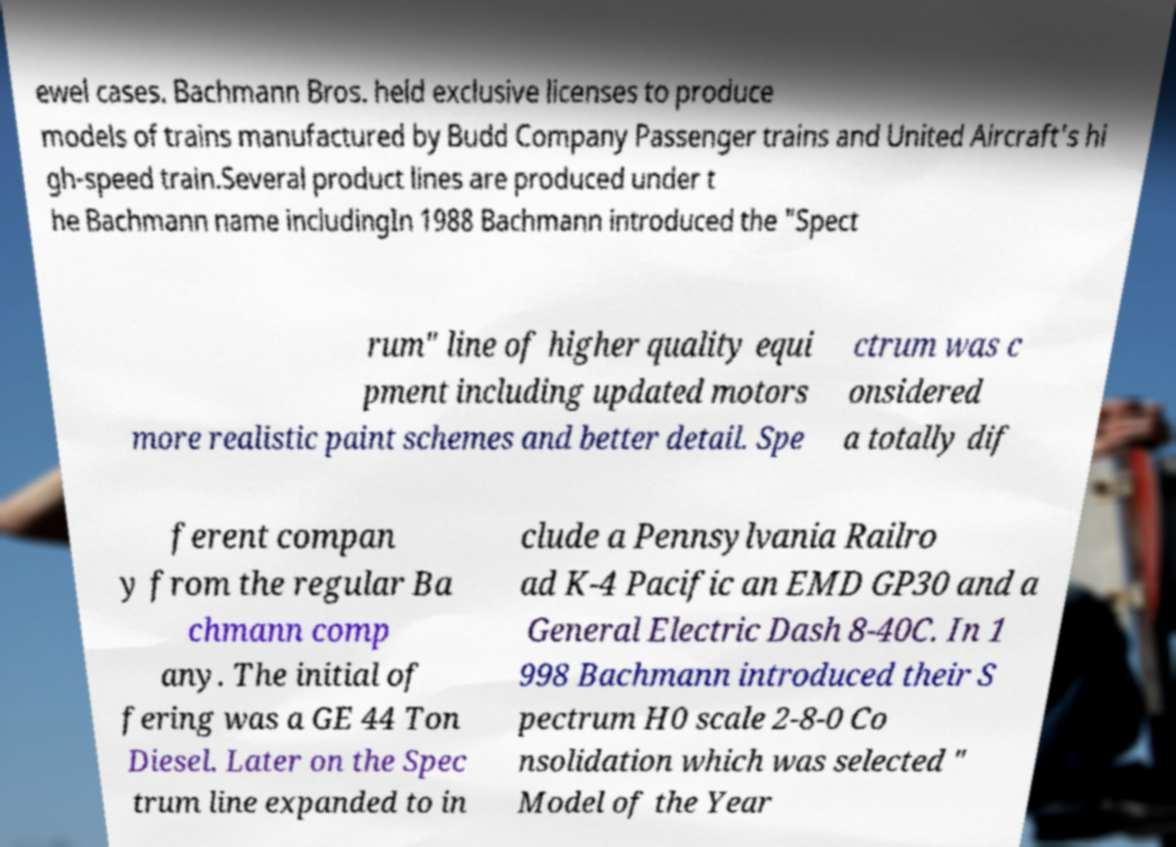Could you extract and type out the text from this image? ewel cases. Bachmann Bros. held exclusive licenses to produce models of trains manufactured by Budd Company Passenger trains and United Aircraft's hi gh-speed train.Several product lines are produced under t he Bachmann name includingIn 1988 Bachmann introduced the "Spect rum" line of higher quality equi pment including updated motors more realistic paint schemes and better detail. Spe ctrum was c onsidered a totally dif ferent compan y from the regular Ba chmann comp any. The initial of fering was a GE 44 Ton Diesel. Later on the Spec trum line expanded to in clude a Pennsylvania Railro ad K-4 Pacific an EMD GP30 and a General Electric Dash 8-40C. In 1 998 Bachmann introduced their S pectrum H0 scale 2-8-0 Co nsolidation which was selected " Model of the Year 